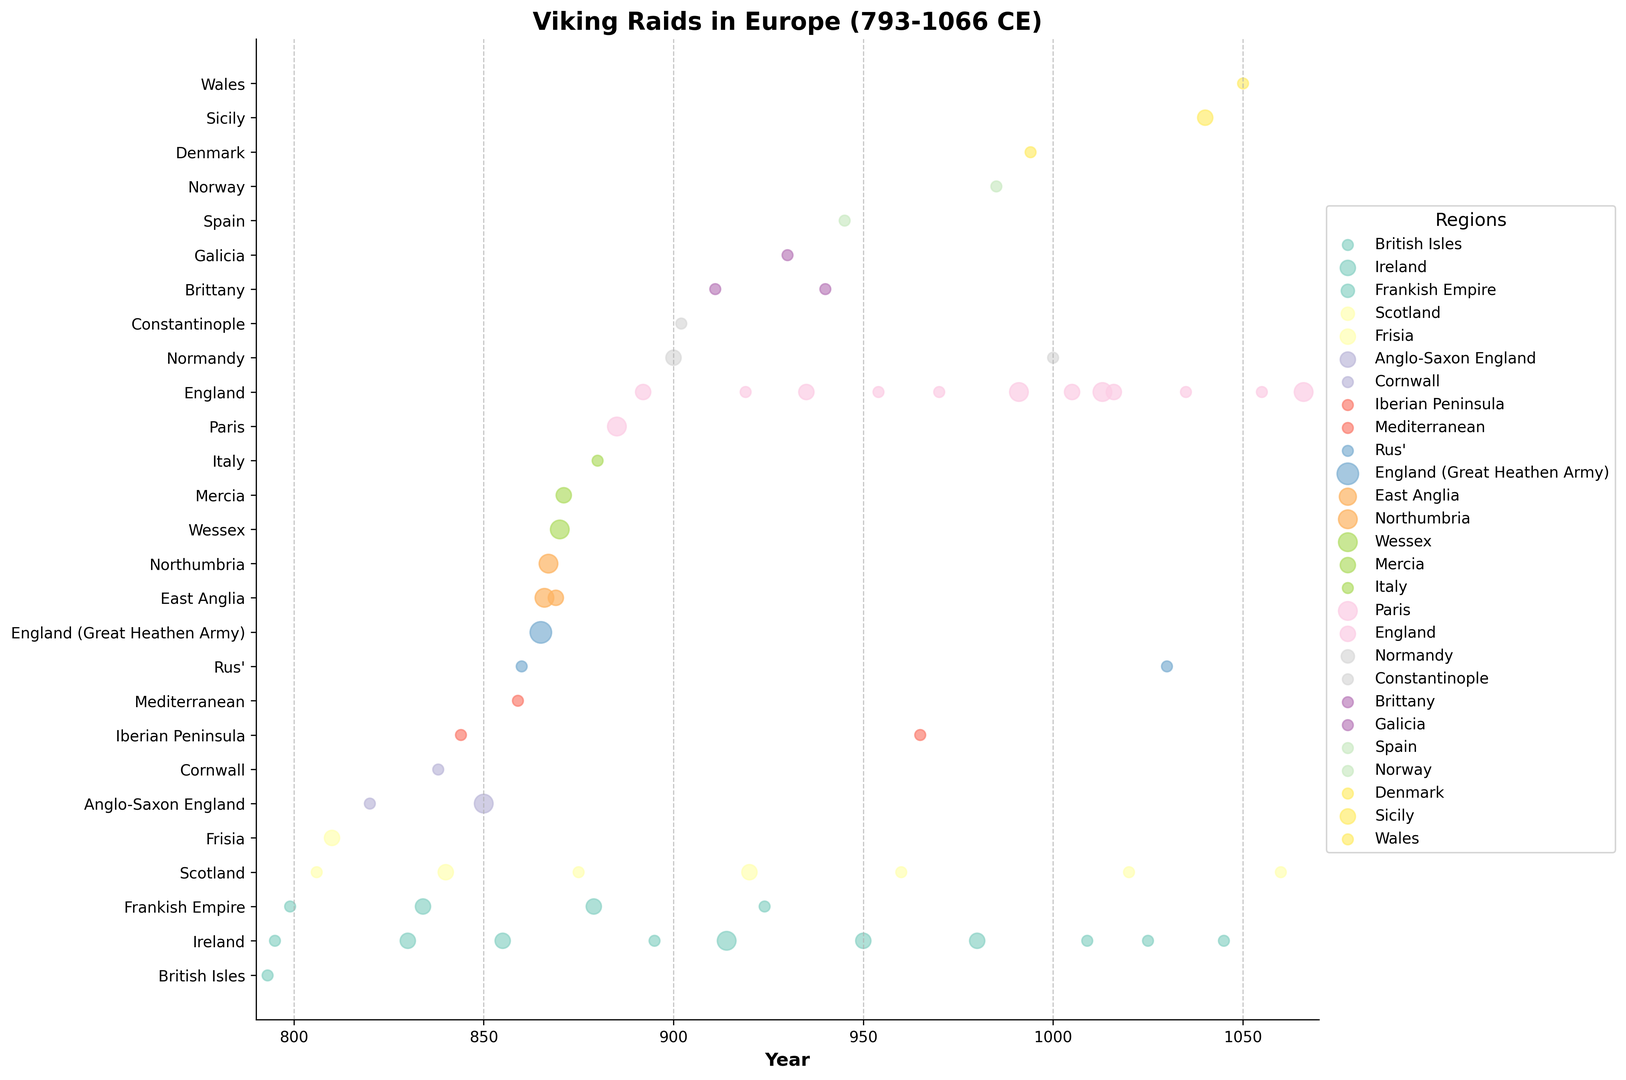What region experienced the highest frequency of raids in 865 CE? By examining the figure, look for the year 865 and identify which region has the largest circle, indicating the highest frequency. The largest circle corresponds to 'England (Great Heathen Army)' with a frequency of 4.
Answer: England (Great Heathen Army) Which region had more raids in 850 CE: Anglo-Saxon England or Frankish Empire? Locate the year 850 on the figure and compare the frequencies of raids in 'Anglo-Saxon England' and 'Frankish Empire'. The size of markers for 'Anglo-Saxon England' is larger, indicating a higher frequency of raids (3 compared to 2).
Answer: Anglo-Saxon England What is the sum of raid frequencies in the British Isles from 793 to 1066 CE? Sum the frequencies of raids in 'British Isles' over the years. The figure shows markers only for the year 793 with a frequency of 1.
Answer: 1 Which region, between 840 and 900 CE, experienced an increasing trend in raid frequency? Look for regions where the size of the markers increases from 840 to 900 CE. 'England' has increasing raid frequencies from 880, 885, to 892. Therefore, 'England' shows an increasing trend in raid frequency in this period.
Answer: England What region had the most uniformly frequent raids during the 9th century? Check for regions that have fairly consistent marker sizes during the 9th century (800-899 CE). 'Ireland' has consistent marker sizes with frequencies primarily around 2 throughout the century.
Answer: Ireland Which regions experienced Viking raids both in the early 9th century (before 850 CE) and the late 11th century (after 1000 CE)? Identify regions with markers in both specified time periods. 'Ireland' and 'Scotland' both have raids in the early 9th century (before 850 CE) and entries in the late 11th century (after 1000 CE).
Answer: Ireland, Scotland Between 900 and 950 CE, which region saw the most frequent raids? Focus on the period 900-950 CE and look for the region with the largest total size of markers. 'England' and 'Ireland' are prominent, with 'Ireland' having more frequent markers (3 in 914, 2 in 950).
Answer: Ireland How many unique regions experienced at least one Viking raid throughout the entire time span? Count the unique regions presented on the y-axis of the figure. The plot includes regions such as 'British Isles', 'Ireland', 'Frankish Empire', 'Scotland', 'Anglo-Saxon England', 'Cornwall', 'Iberian Peninsula', 'Mediterranean', 'Rus', 'England (Great Heathen Army)', 'East Anglia', 'Northumbria', 'Wessex', 'Mercia', 'Italy', 'Paris', 'Normandy', 'Constantinople', 'Brittany', 'Spain', 'Norway', 'Denmark', 'Galicia', 'Sicily', and 'Wales'.
Answer: 25 In which year did the Paris region experience a Viking raid, and what was the raid frequency? Examine the figure for the 'Paris' region and find the corresponding year of the raid along with the marker size. The year is 885 with a frequency of 3.
Answer: 885, 3 